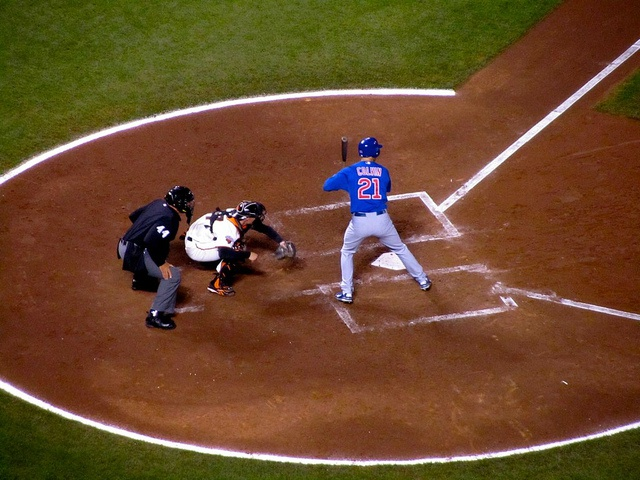Describe the objects in this image and their specific colors. I can see people in darkgreen, lavender, darkblue, and blue tones, people in darkgreen, black, purple, navy, and maroon tones, people in darkgreen, black, white, maroon, and gray tones, baseball glove in darkgreen, gray, black, and purple tones, and baseball bat in darkgreen, black, maroon, brown, and gray tones in this image. 